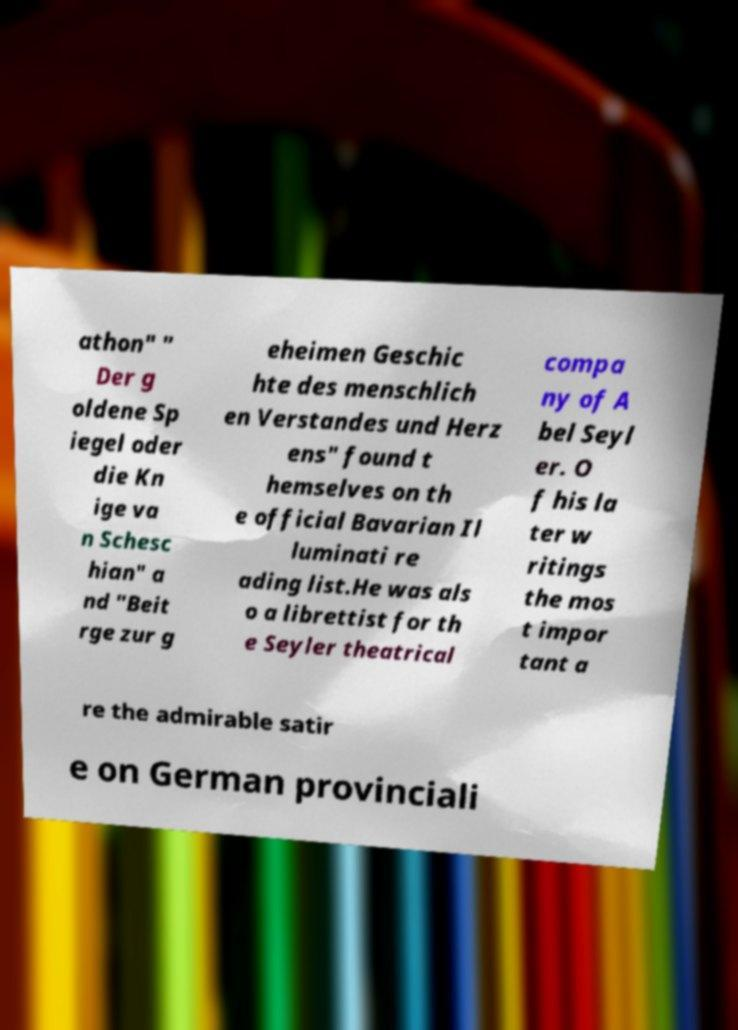Please read and relay the text visible in this image. What does it say? athon" " Der g oldene Sp iegel oder die Kn ige va n Schesc hian" a nd "Beit rge zur g eheimen Geschic hte des menschlich en Verstandes und Herz ens" found t hemselves on th e official Bavarian Il luminati re ading list.He was als o a librettist for th e Seyler theatrical compa ny of A bel Seyl er. O f his la ter w ritings the mos t impor tant a re the admirable satir e on German provinciali 